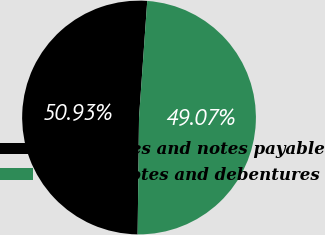<chart> <loc_0><loc_0><loc_500><loc_500><pie_chart><fcel>Mortgages and notes payable<fcel>Senior notes and debentures<nl><fcel>50.93%<fcel>49.07%<nl></chart> 